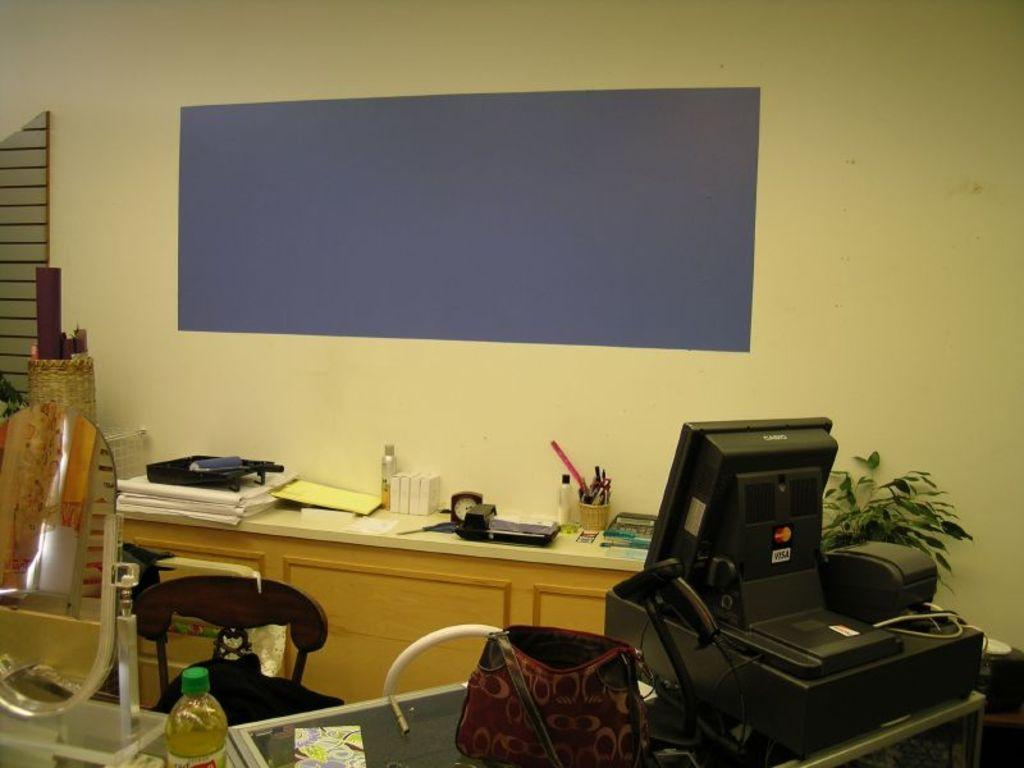What type of furniture is present in the image? There is a chair and a table in the image. What type of electronic device is present in the image? There is a monitor in the image. What type of office equipment is present in the image? There is a bill printer in the image. What type of plant is present in the image? There is a plant in the image. What type of timekeeping device is present in the image? There is a clock in the image. What type of personal item is present in the image? There is a handbag in the image. What type of wall feature is present in the image? There is a wall with a notice board in the image. How many doctors are present in the image? There are no doctors present in the image. What type of cough medicine is present in the image? There is no cough medicine present in the image. 